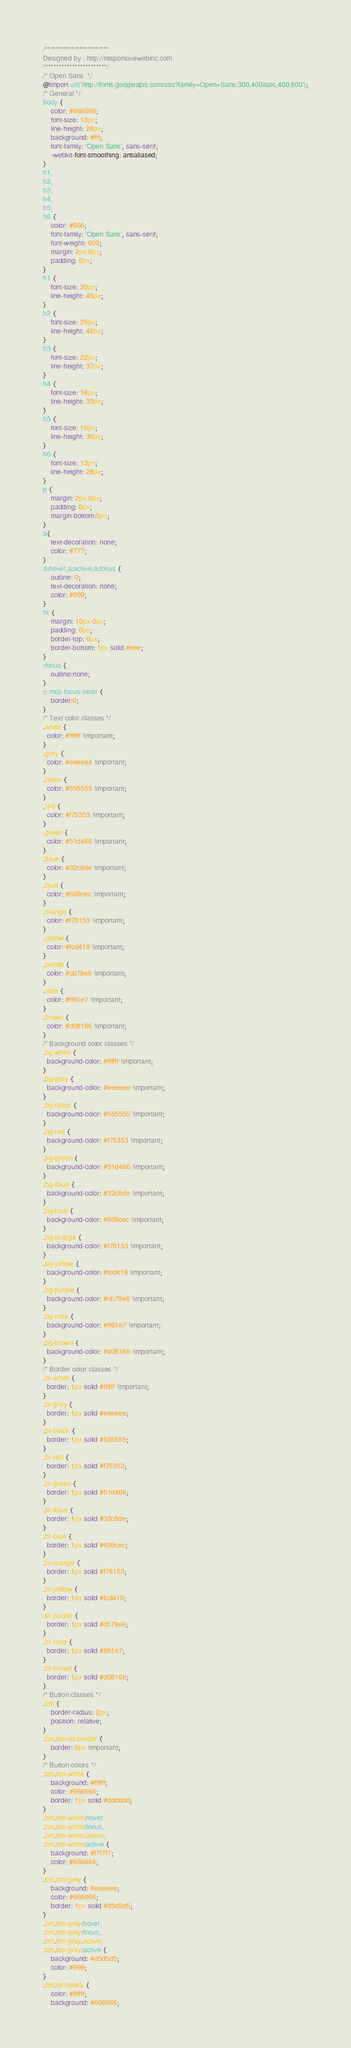Convert code to text. <code><loc_0><loc_0><loc_500><loc_500><_CSS_>/************************
Designed by : http://responsivewebinc.com
************************/
/* Open Sans  */
@import url('http://fonts.googleapis.com/css?family=Open+Sans:300,400italic,400,600');
/* General */
body {
	color: #666666;
	font-size: 13px;
	line-height: 28px;
	background: #fff;
	font-family: 'Open Sans', sans-serif;
	-webkit-font-smoothing: antialiased;
}
h1,
h2,
h3,
h4,
h5,
h6 {
	color: #666;
	font-family: 'Open Sans', sans-serif;
	font-weight: 600;
	margin: 2px 0px;
	padding: 0px;
}
h1 {
	font-size: 30px;
	line-height: 45px;
}
h2 {
	font-size: 25px;
	line-height: 40px;
}
h3 {
	font-size: 22px;
	line-height: 37px;
}
h4 {
	font-size: 18px;
	line-height: 33px;
}
h5 {
	font-size: 15px;
	line-height: 30px;
}
h6 {
	font-size: 13px;
	line-height: 28px;
}
p {
	margin: 2px 0px;
	padding: 0px;
	margin-bottom:5px;
}
a{
	text-decoration: none;
	color: #777;
}
a:hover,a:active,a:focus {
	outline: 0;
	text-decoration: none;
	color: #999;
}
hr {
	margin: 10px 0px;
	padding: 0px;
	border-top: 0px;
	border-bottom: 1px solid #eee;
}
:focus {
	outline:none;
}
::-moz-focus-inner {
	border:0;
}
/* Text color classes */
.white {
  color: #ffffff !important;
}
.grey {
  color: #eeeeee !important;
}
.black {
  color: #555555 !important;
}
.red {
  color: #f75353 !important;
}
.green {
  color: #51d466 !important;
}
.lblue {
  color: #32c8de !important;
}
.blue {
  color: #609cec !important;
}
.orange {
  color: #f78153 !important;
}
.yellow {
  color: #fcd419 !important;
}
.purple {
  color: #cb79e6 !important;
}
.rose {
  color: #ff61e7 !important;
}
.brown {
  color: #d08166 !important;
}
/* Background color classes */
.bg-white {
  background-color: #ffffff !important;
}
.bg-grey {
  background-color: #eeeeee !important;
}
.bg-black {
  background-color: #555555 !important;
}
.bg-red {
  background-color: #f75353 !important;
}
.bg-green {
  background-color: #51d466 !important;
}
.bg-lblue {
  background-color: #32c8de !important;
}
.bg-blue {
  background-color: #609cec !important;
}
.bg-orange {
  background-color: #f78153 !important;
}
.bg-yellow {
  background-color: #fcd419 !important;
}
.bg-purple {
  background-color: #cb79e6 !important;
}
.bg-rose {
  background-color: #ff61e7 !important;
}
.bg-brown {
  background-color: #d08166 !important;
}
/* Border color classes */
.br-white {
  border: 1px solid #ffffff !important;
}
.br-grey {
  border: 1px solid #eeeeee;
}
.br-black {
  border: 1px solid #555555;
}
.br-red {
  border: 1px solid #f75353;
}
.br-green {
  border: 1px solid #51d466;
}
.br-lblue {
  border: 1px solid #32c8de;
}
.br-blue {
  border: 1px solid #609cec;
}
.br-orange {
  border: 1px solid #f78153;
}
.br-yellow {
  border: 1px solid #fcd419;
}
.br-purple {
  border: 1px solid #cb79e6;
}
.br-rose {
  border: 1px solid #ff61e7;
}
.br-brown {
  border: 1px solid #d08166;
}
/* Button classes */
.btn {
	border-radius: 2px;
	position: relative;
}
.btn.btn-no-border {
	border: 0px !important;
}
/* Button colors */
.btn.btn-white {
	background: #ffffff;
	color: #666666;
	border: 1px solid #dddddd;
}
.btn.btn-white:hover,
.btn.btn-white:focus,
.btn.btn-white.active,
.btn.btn-white:active {
	background: #f7f7f7;
	color: #666666;
}
.btn.btn-grey {
	background: #eeeeee;
	color: #666666;
	border: 1px solid #d5d5d5;
}
.btn.btn-grey:hover,
.btn.btn-grey:focus,
.btn.btn-grey.active,
.btn.btn-grey:active {
	background: #d5d5d5;
	color: #999;
}
.btn.btn-black {
	color: #ffffff;
	background: #666666;</code> 